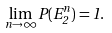Convert formula to latex. <formula><loc_0><loc_0><loc_500><loc_500>\lim _ { n \to \infty } P ( E _ { 2 } ^ { n } ) = 1 .</formula> 